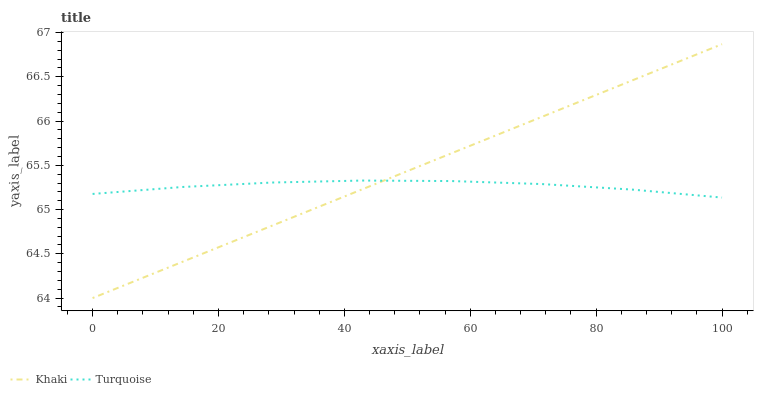Does Turquoise have the minimum area under the curve?
Answer yes or no. Yes. Does Khaki have the maximum area under the curve?
Answer yes or no. Yes. Does Khaki have the minimum area under the curve?
Answer yes or no. No. Is Khaki the smoothest?
Answer yes or no. Yes. Is Turquoise the roughest?
Answer yes or no. Yes. Is Khaki the roughest?
Answer yes or no. No. Does Khaki have the lowest value?
Answer yes or no. Yes. Does Khaki have the highest value?
Answer yes or no. Yes. Does Turquoise intersect Khaki?
Answer yes or no. Yes. Is Turquoise less than Khaki?
Answer yes or no. No. Is Turquoise greater than Khaki?
Answer yes or no. No. 